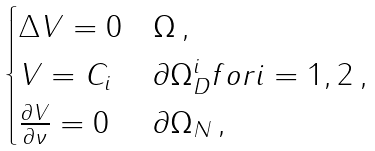<formula> <loc_0><loc_0><loc_500><loc_500>\begin{cases} \Delta V = 0 & \Omega \, , \\ V = C _ { i } & \partial \Omega _ { D } ^ { i } f o r i = 1 , 2 \, , \\ \frac { \partial V } { \partial \nu } = 0 & \partial \Omega _ { N } \, , \end{cases}</formula> 